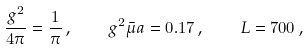Convert formula to latex. <formula><loc_0><loc_0><loc_500><loc_500>\frac { g ^ { 2 } } { 4 \pi } = \frac { 1 } { \pi } \, , \quad g ^ { 2 } \bar { \mu } a = 0 . 1 7 \, , \quad L = 7 0 0 \, ,</formula> 